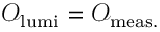Convert formula to latex. <formula><loc_0><loc_0><loc_500><loc_500>\begin{array} { r l } { \mathcal { O } _ { l u m i } = \mathcal { O } _ { m e a s . } } \end{array}</formula> 